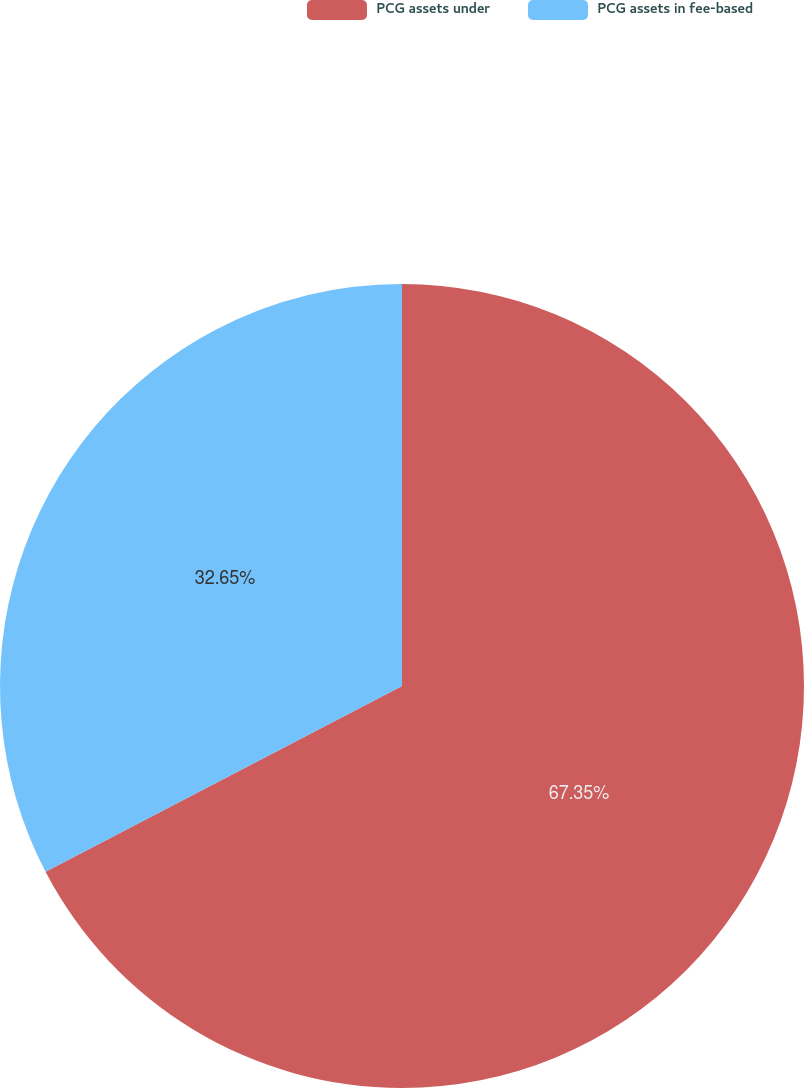<chart> <loc_0><loc_0><loc_500><loc_500><pie_chart><fcel>PCG assets under<fcel>PCG assets in fee-based<nl><fcel>67.35%<fcel>32.65%<nl></chart> 